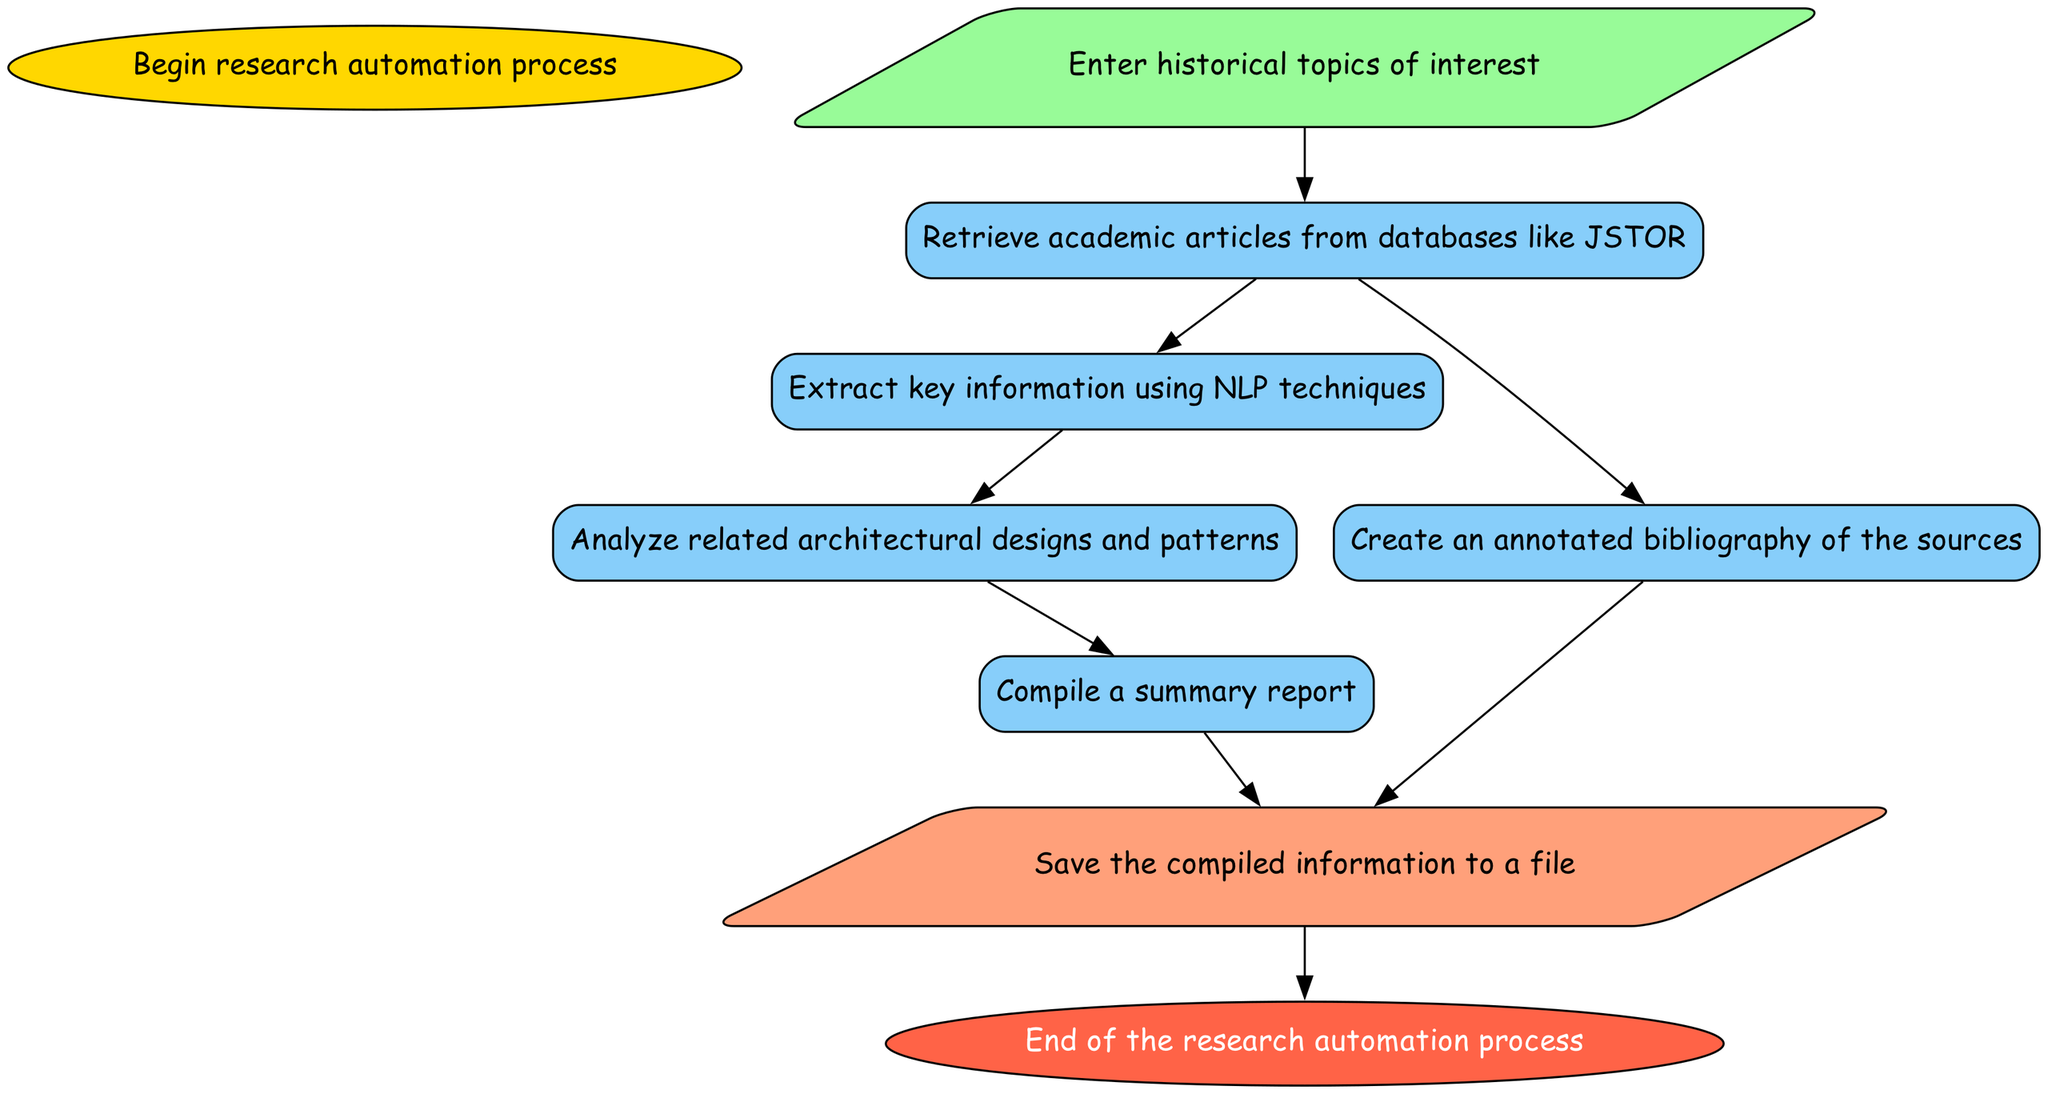What is the first step in the flowchart? The first step, or the start node, is labeled "Begin research automation process." This is the initial action before any input is given or processes are undertaken.
Answer: Begin research automation process How many processes are there in total? Upon reviewing the flowchart, there are five processes labeled: Fetch Academic Articles, Extract Key Information, Analyze Historical Architecture, Compile Summary Report, and Generate Annotated Bibliography, making a total of five processes.
Answer: Five Which node depends on the "Fetch Academic Articles" node? The nodes that depend on "Fetch Academic Articles" are "Extract Key Information" and "Generate Annotated Bibliography." Each of these nodes requires the completion of the "Fetch Academic Articles" node to move forward to their respective tasks.
Answer: Extract Key Information, Generate Annotated Bibliography What type of node is "Save to File"? The "Save to File" node is classified as an output type node, indicating that it represents a final step where the compiled information is stored as a file.
Answer: Output What is the last step of the automation process? The last step is the "End of the research automation process." This indicates that no further actions are taken after this point, marking the completion of the entire flow.
Answer: End of the research automation process What are the dependencies of the "Compile Summary Report" node? The "Compile Summary Report" node depends on the "Analyze Historical Architecture" node, meaning it requires this task to be completed before it can execute its own processes.
Answer: Analyze Historical Architecture How many input nodes are present in the flowchart? The flowchart contains one input node, labeled "Enter historical topics of interest," which is the sole point for user input.
Answer: One What type of information is extracted using NLP techniques? The information extracted using NLP techniques refers to key information that is vital for understanding the academic articles and historical context. This indicates a focus on textual data processing.
Answer: Key information 